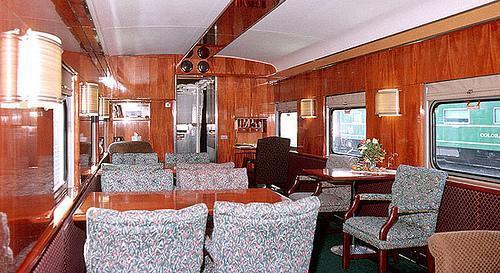How many dining tables are visible?
Give a very brief answer. 1. How many chairs are visible?
Give a very brief answer. 4. 